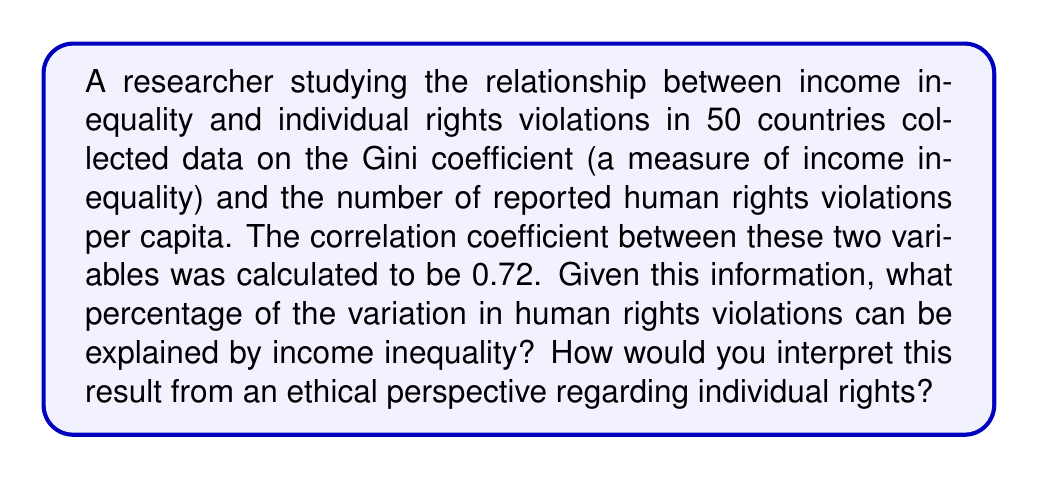Can you solve this math problem? To solve this problem, we need to follow these steps:

1. Understand the meaning of the correlation coefficient:
   The correlation coefficient (r) measures the strength and direction of a linear relationship between two variables. It ranges from -1 to +1.

2. Calculate the coefficient of determination:
   The coefficient of determination (R²) is the square of the correlation coefficient. It represents the proportion of variance in the dependent variable that is predictable from the independent variable.

   R² = r²
   R² = (0.72)² = 0.5184

3. Convert to percentage:
   Multiply the R² value by 100 to get the percentage.

   Percentage = R² × 100 = 0.5184 × 100 = 51.84%

4. Interpretation:
   51.84% of the variation in human rights violations can be explained by income inequality.

From an ethical perspective on individual rights:

This result suggests a moderate to strong relationship between income inequality and human rights violations. It implies that as income inequality increases, there's a tendency for more human rights violations to occur. This raises ethical concerns about the impact of economic disparities on fundamental human rights.

However, it's important to note that correlation does not imply causation. Other factors may be influencing both variables or mediating the relationship. Additionally, about 48.16% of the variation in human rights violations is not explained by income inequality, indicating that other factors play significant roles.

From a philosophical standpoint, this relationship challenges the notion of equal rights in societies with high income inequality. It suggests that economic systems may have profound implications for the protection and realization of individual rights, raising questions about the ethical responsibilities of governments and societies in addressing income inequality as a means of safeguarding human rights.
Answer: 51.84%; Moderate to strong relationship between income inequality and human rights violations, raising ethical concerns about economic disparities' impact on individual rights. 